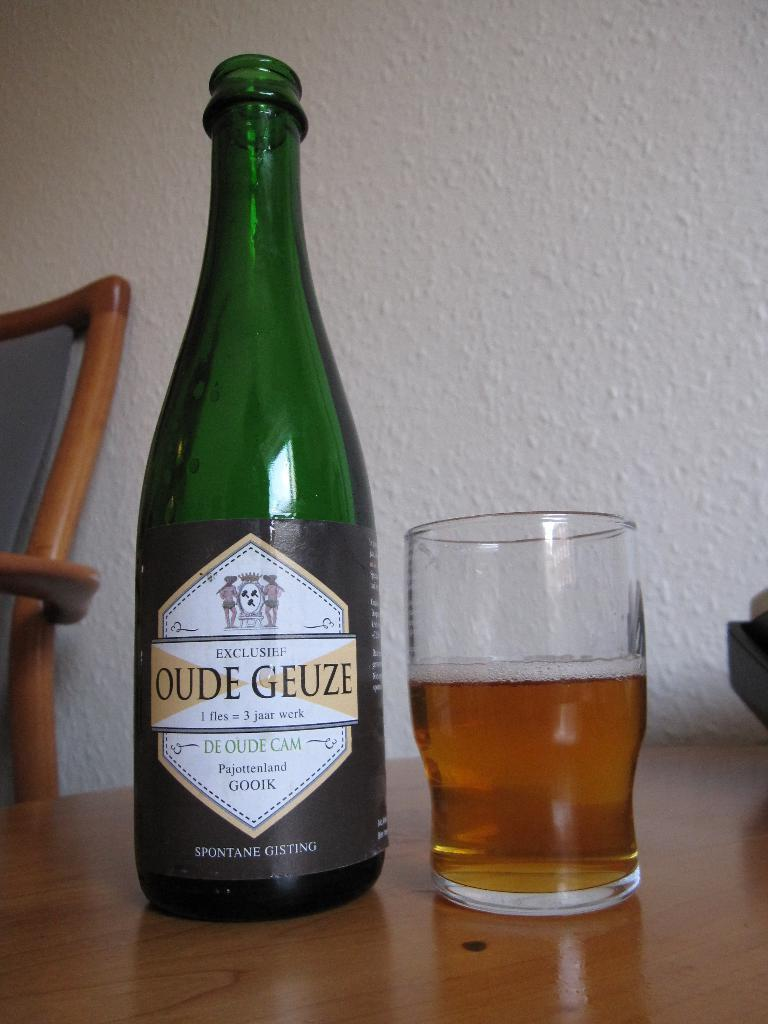<image>
Summarize the visual content of the image. A glass next to a bottle of OUDE GUEZE 